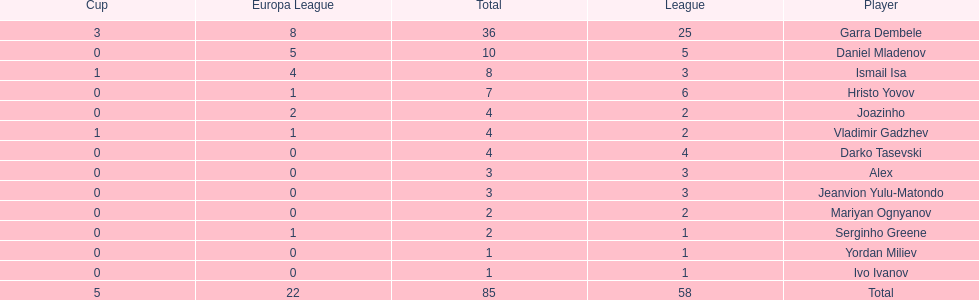Which players only scored one goal? Serginho Greene, Yordan Miliev, Ivo Ivanov. Parse the table in full. {'header': ['Cup', 'Europa League', 'Total', 'League', 'Player'], 'rows': [['3', '8', '36', '25', 'Garra Dembele'], ['0', '5', '10', '5', 'Daniel Mladenov'], ['1', '4', '8', '3', 'Ismail Isa'], ['0', '1', '7', '6', 'Hristo Yovov'], ['0', '2', '4', '2', 'Joazinho'], ['1', '1', '4', '2', 'Vladimir Gadzhev'], ['0', '0', '4', '4', 'Darko Tasevski'], ['0', '0', '3', '3', 'Alex'], ['0', '0', '3', '3', 'Jeanvion Yulu-Matondo'], ['0', '0', '2', '2', 'Mariyan Ognyanov'], ['0', '1', '2', '1', 'Serginho Greene'], ['0', '0', '1', '1', 'Yordan Miliev'], ['0', '0', '1', '1', 'Ivo Ivanov'], ['5', '22', '85', '58', 'Total']]} 